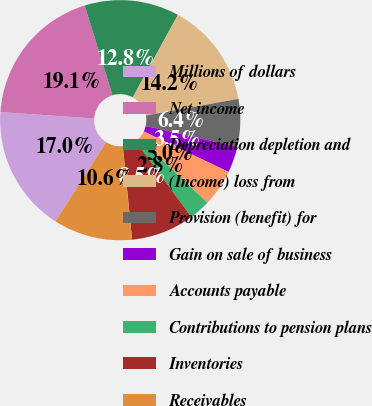<chart> <loc_0><loc_0><loc_500><loc_500><pie_chart><fcel>Millions of dollars<fcel>Net income<fcel>Depreciation depletion and<fcel>(Income) loss from<fcel>Provision (benefit) for<fcel>Gain on sale of business<fcel>Accounts payable<fcel>Contributions to pension plans<fcel>Inventories<fcel>Receivables<nl><fcel>17.01%<fcel>19.14%<fcel>12.76%<fcel>14.18%<fcel>6.39%<fcel>3.55%<fcel>4.97%<fcel>2.85%<fcel>8.51%<fcel>10.64%<nl></chart> 